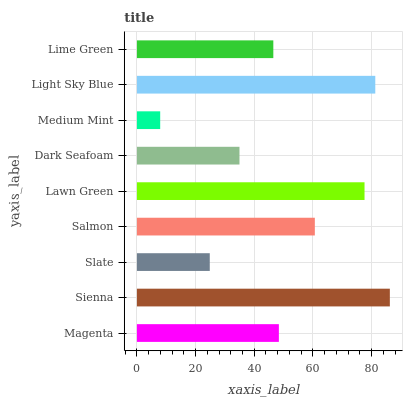Is Medium Mint the minimum?
Answer yes or no. Yes. Is Sienna the maximum?
Answer yes or no. Yes. Is Slate the minimum?
Answer yes or no. No. Is Slate the maximum?
Answer yes or no. No. Is Sienna greater than Slate?
Answer yes or no. Yes. Is Slate less than Sienna?
Answer yes or no. Yes. Is Slate greater than Sienna?
Answer yes or no. No. Is Sienna less than Slate?
Answer yes or no. No. Is Magenta the high median?
Answer yes or no. Yes. Is Magenta the low median?
Answer yes or no. Yes. Is Lime Green the high median?
Answer yes or no. No. Is Light Sky Blue the low median?
Answer yes or no. No. 